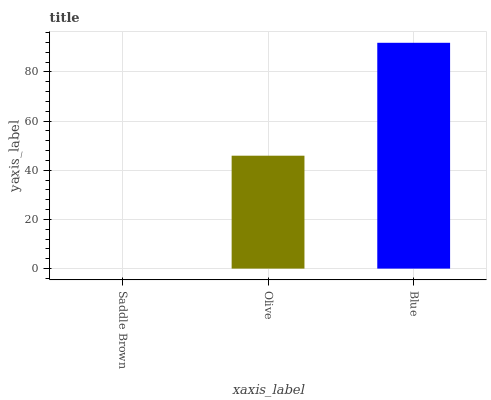Is Saddle Brown the minimum?
Answer yes or no. Yes. Is Blue the maximum?
Answer yes or no. Yes. Is Olive the minimum?
Answer yes or no. No. Is Olive the maximum?
Answer yes or no. No. Is Olive greater than Saddle Brown?
Answer yes or no. Yes. Is Saddle Brown less than Olive?
Answer yes or no. Yes. Is Saddle Brown greater than Olive?
Answer yes or no. No. Is Olive less than Saddle Brown?
Answer yes or no. No. Is Olive the high median?
Answer yes or no. Yes. Is Olive the low median?
Answer yes or no. Yes. Is Blue the high median?
Answer yes or no. No. Is Blue the low median?
Answer yes or no. No. 